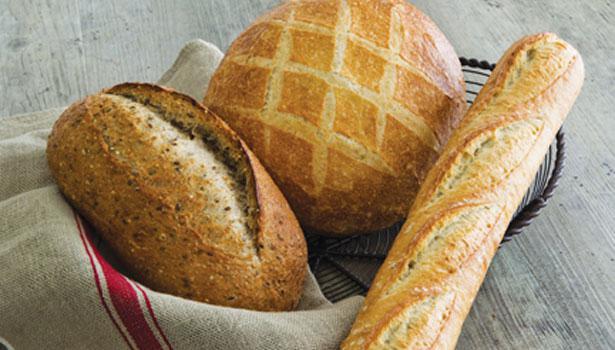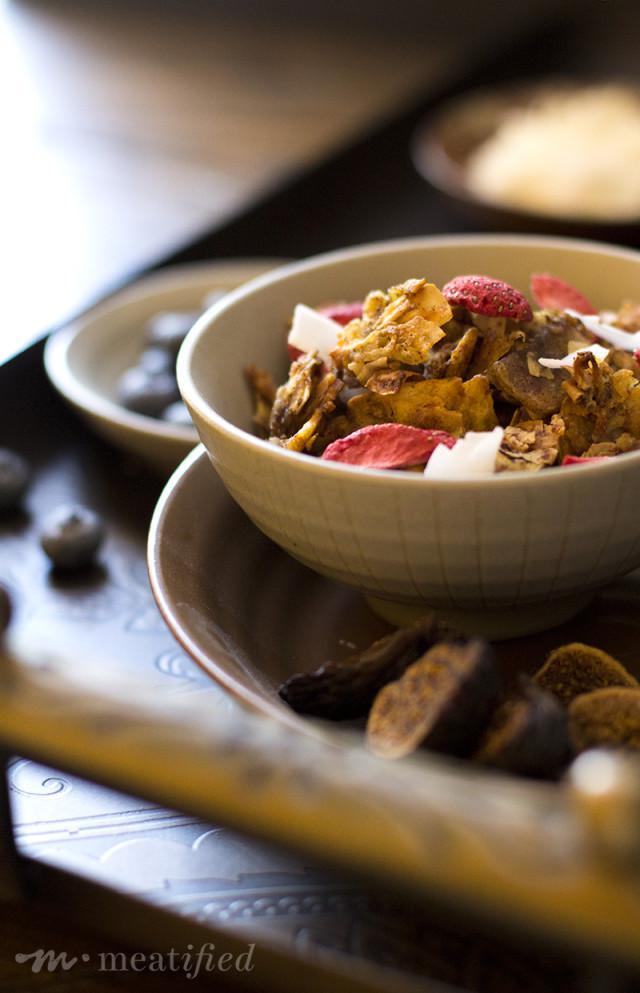The first image is the image on the left, the second image is the image on the right. Assess this claim about the two images: "In at least one image there are at least 4 strawberry slices in backed mix.". Correct or not? Answer yes or no. Yes. The first image is the image on the left, the second image is the image on the right. For the images shown, is this caption "At least one photo shows a menu that is hand-written and a variety of sweets on pedestals of different heights." true? Answer yes or no. No. 